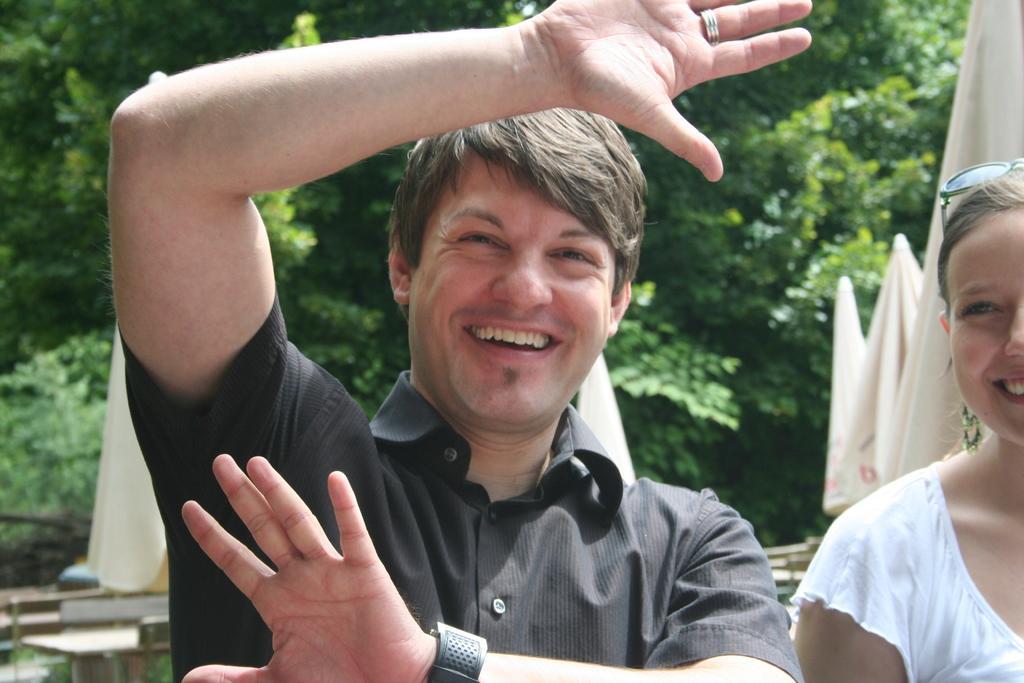Could you give a brief overview of what you see in this image? In this image we can see two persons. Behind the persons we can see the clothes and wooden objects. In the background, we can see a group of trees. 